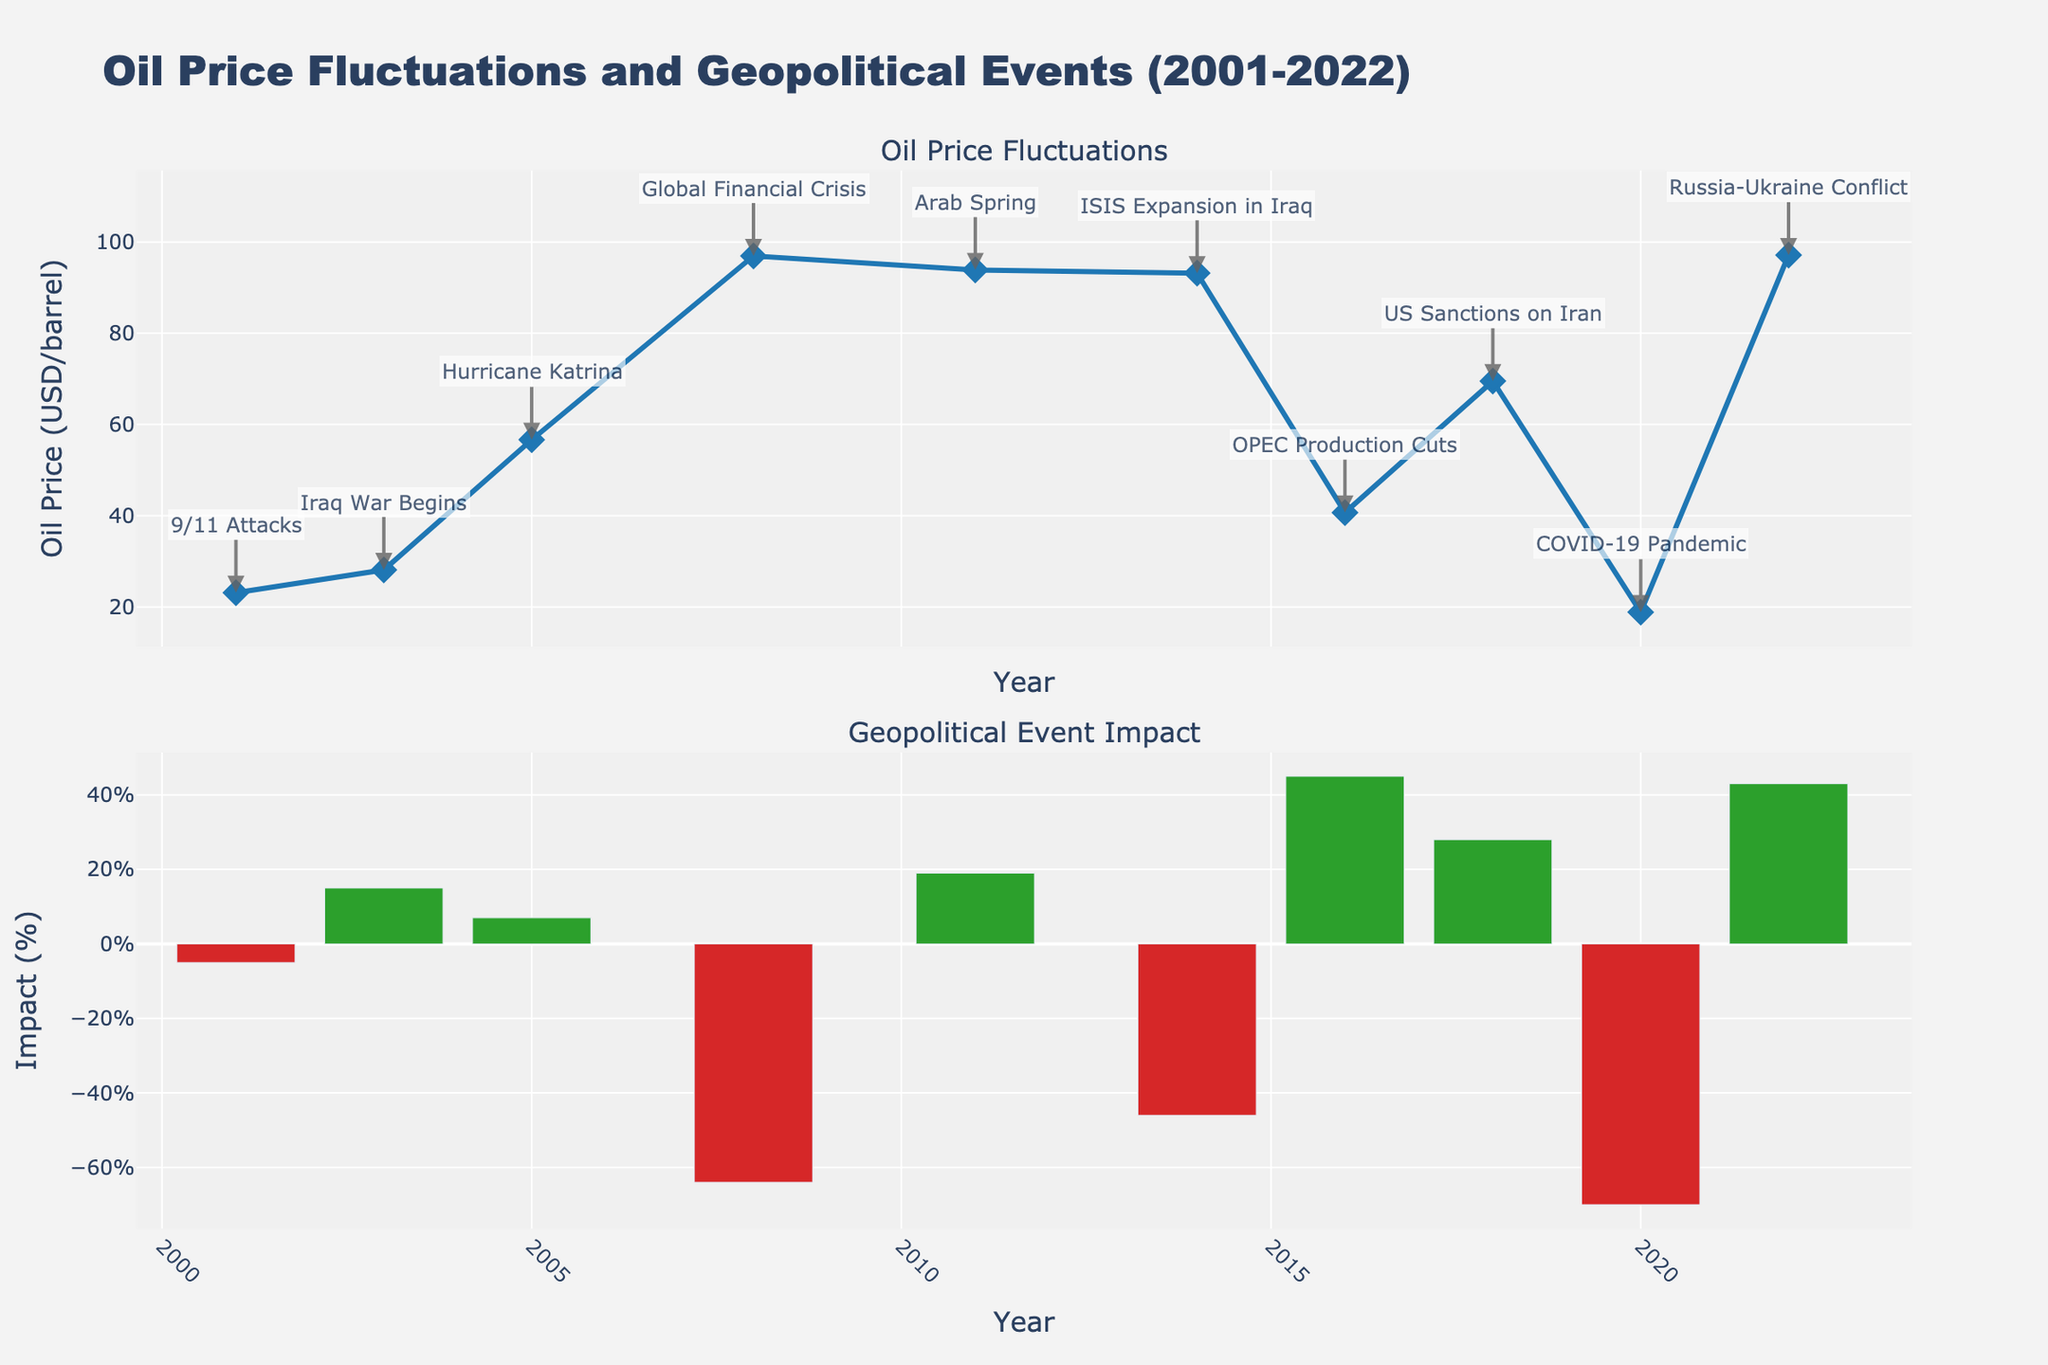what is the title of the figure? The title is displayed at the top of the figure. It reads "Oil Price Fluctuations and Geopolitical Events (2001-2022)."
Answer: Oil Price Fluctuations and Geopolitical Events (2001-2022) How many major geopolitical events are annotated in the figure? The annotations are visible in the first subplot where each point corresponding to a year has a label indicating the event. Counting these labels, there are 10 annotations.
Answer: 10 What year had the highest oil price, and what was the price? By examining the first subplot, the highest data point on the y-axis corresponding to oil price is around "2008," where the price is labeled approximately at "96.94 USD/barrel."
Answer: 2008, 96.94 USD/barrel Compare the impact percentages of the events in 2008 and 2020. Which had a greater negative impact? The second subplot shows the impact percentages with bars. In 2008, the impact was -64%, and in 2020, it was -70%. The 2020 event had a greater negative impact.
Answer: 2020 What is the color used to represent positive event impacts in the second subplot? Positive impacts are represented by green bars and can be seen from bars that are above the x-axis in the second subplot.
Answer: Green Was there any event that caused the oil price to increase by more than 40%? If so, name the event. By examining the second subplot for bars exceeding a 40% impact, the "OPEC Production Cuts" in "2016" shows a positive impact of 45%.
Answer: OPEC Production Cuts Which event is associated with the largest drop in oil prices, and what is the percentage drop? The second subplot shows the negative impacts with red bars. The largest drop occurs in "2020" during the "COVID-19 Pandemic" with a -70% impact.
Answer: COVID-19 Pandemic, -70% Calculate the average oil price from 2001 to 2022. Sum up all the oil prices and divide by the total number of data points. (23.12 + 28.10 + 56.64 + 96.94 + 93.88 + 93.17 + 40.68 + 69.51 + 18.84 + 97.13) / 10 = 61.701
Answer: 61.70 USD/barrel In which year did the Arab Spring occur, and what was its corresponding oil price and impact percentage? Referencing the labeled annotations in the first subplot and matching it to the events in the second subplot, the "Arab Spring" occurred in "2011" with an oil price of "93.88 USD/barrel" and a "19%" impact.
Answer: 2011, 93.88 USD/barrel, 19% Between 2014 and 2018, did the oil price increase or decrease, and by how much? By looking at the first subplot, the oil price in "2014" was "93.17 USD/barrel" and in "2018" it was "69.51 USD/barrel." Calculate the difference which is 93.17 - 69.51 = 23.66, indicating a decrease.
Answer: Decrease, 23.66 USD/barrel 